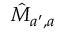Convert formula to latex. <formula><loc_0><loc_0><loc_500><loc_500>\hat { M } _ { a ^ { \prime } , a }</formula> 